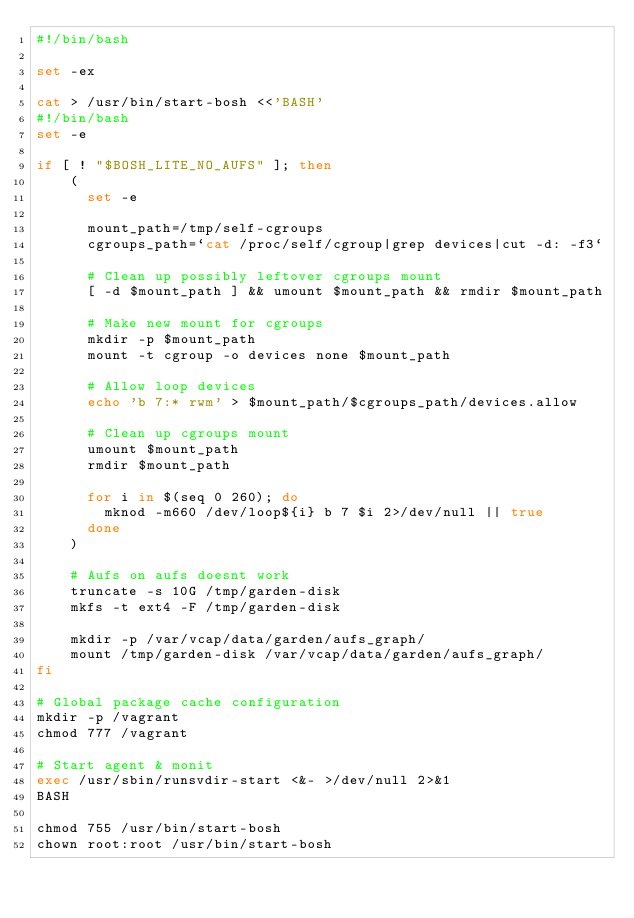<code> <loc_0><loc_0><loc_500><loc_500><_Bash_>#!/bin/bash

set -ex

cat > /usr/bin/start-bosh <<'BASH'
#!/bin/bash
set -e

if [ ! "$BOSH_LITE_NO_AUFS" ]; then
	(
	  set -e

	  mount_path=/tmp/self-cgroups
	  cgroups_path=`cat /proc/self/cgroup|grep devices|cut -d: -f3`

	  # Clean up possibly leftover cgroups mount
	  [ -d $mount_path ] && umount $mount_path && rmdir $mount_path

	  # Make new mount for cgroups
	  mkdir -p $mount_path
	  mount -t cgroup -o devices none $mount_path

	  # Allow loop devices
	  echo 'b 7:* rwm' > $mount_path/$cgroups_path/devices.allow

	  # Clean up cgroups mount
	  umount $mount_path
	  rmdir $mount_path

	  for i in $(seq 0 260); do
	  	mknod -m660 /dev/loop${i} b 7 $i 2>/dev/null || true
	  done
	)

	# Aufs on aufs doesnt work
	truncate -s 10G /tmp/garden-disk
	mkfs -t ext4 -F /tmp/garden-disk

	mkdir -p /var/vcap/data/garden/aufs_graph/
	mount /tmp/garden-disk /var/vcap/data/garden/aufs_graph/
fi

# Global package cache configuration
mkdir -p /vagrant
chmod 777 /vagrant

# Start agent & monit
exec /usr/sbin/runsvdir-start <&- >/dev/null 2>&1
BASH

chmod 755 /usr/bin/start-bosh
chown root:root /usr/bin/start-bosh
</code> 